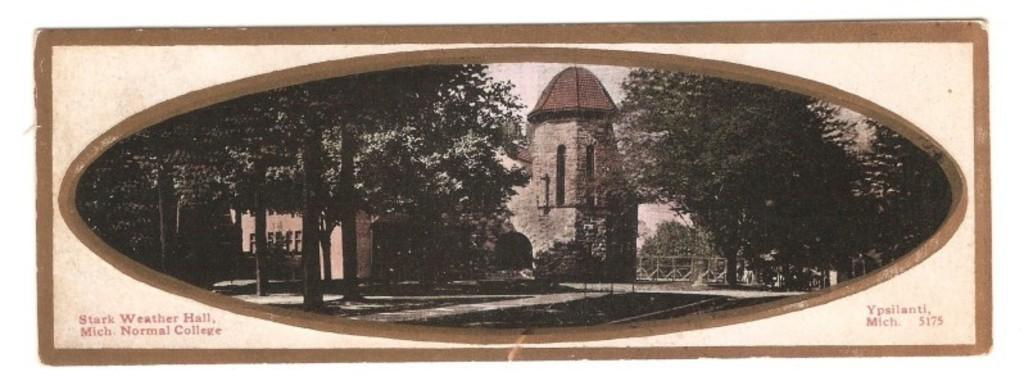What type of object is the image depicting? The image appears to be a photo frame. What natural elements can be seen in the image? There are trees visible in the image. What man-made structures are present in the image? There is a fence and buildings visible in the image. What architectural feature is visible in the buildings? Windows are visible in the image. What is visible at the top of the image? The sky is visible at the top of the image. Where is the memory card located in the image? There is no memory card present in the image, as it is a photo frame and not a digital device. What type of key is used to unlock the fence in the image? There is no key visible in the image, and the fence's locking mechanism is not shown. 